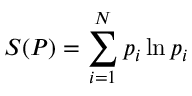Convert formula to latex. <formula><loc_0><loc_0><loc_500><loc_500>S ( P ) = \sum _ { i = 1 } ^ { N } p _ { i } \ln p _ { i }</formula> 